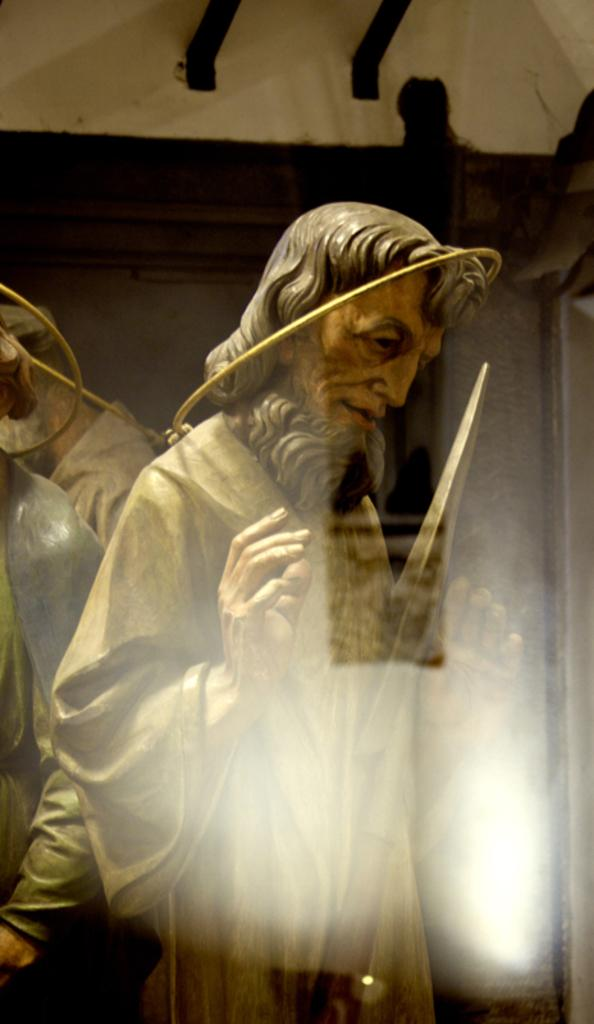What is the main subject of the image? There is a man sculpture in the image. What is the sculpture wearing? The sculpture is wearing a white dress. What can be observed about the sculpture's hair? The sculpture has long hair. What is the color of the wall behind the sculpture? There is a brown wall behind the sculpture. What type of air is being used to cook the beef in the image? There is no mention of air or beef in the image; it features a man sculpture wearing a white dress with long hair in front of a brown wall. 